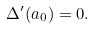<formula> <loc_0><loc_0><loc_500><loc_500>\Delta ^ { \prime } ( a _ { 0 } ) = 0 .</formula> 